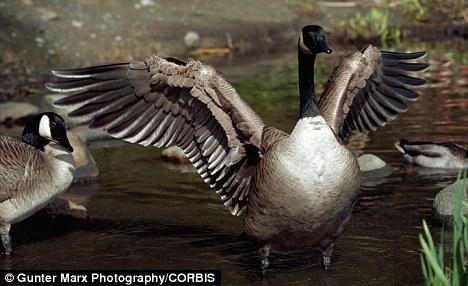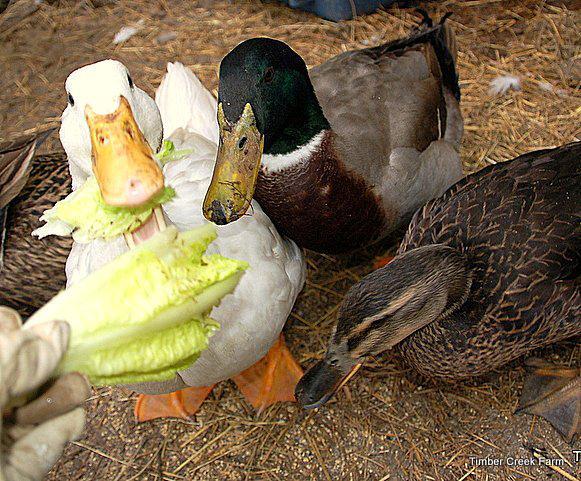The first image is the image on the left, the second image is the image on the right. For the images shown, is this caption "One image shows black-necked Canadian geese standing in shallow water, and the other image includes a white duck eating something." true? Answer yes or no. Yes. 